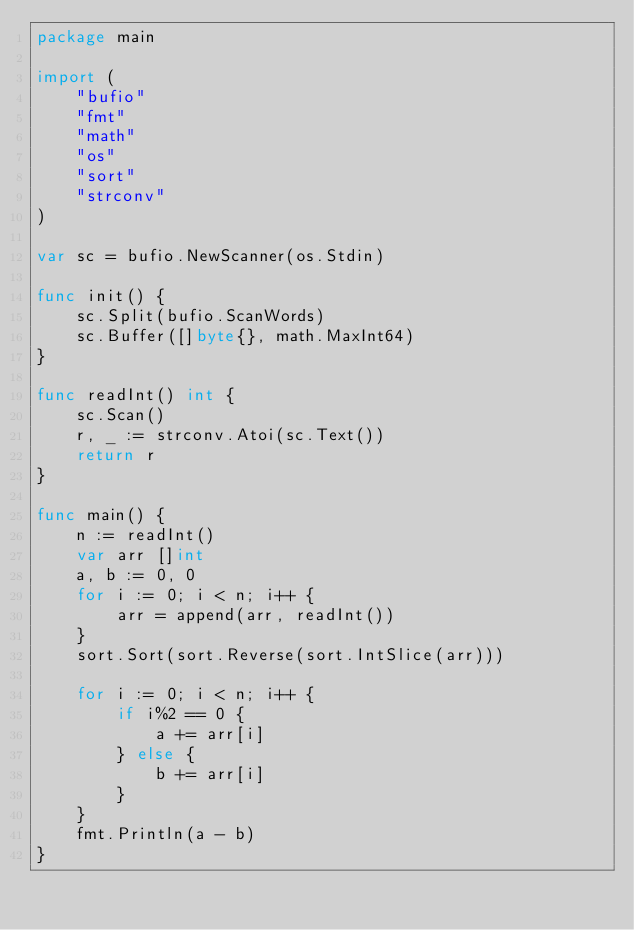Convert code to text. <code><loc_0><loc_0><loc_500><loc_500><_Go_>package main

import (
	"bufio"
	"fmt"
	"math"
	"os"
	"sort"
	"strconv"
)

var sc = bufio.NewScanner(os.Stdin)

func init() {
	sc.Split(bufio.ScanWords)
	sc.Buffer([]byte{}, math.MaxInt64)
}

func readInt() int {
	sc.Scan()
	r, _ := strconv.Atoi(sc.Text())
	return r
}

func main() {
	n := readInt()
	var arr []int
	a, b := 0, 0
	for i := 0; i < n; i++ {
		arr = append(arr, readInt())
	}
	sort.Sort(sort.Reverse(sort.IntSlice(arr)))

	for i := 0; i < n; i++ {
		if i%2 == 0 {
			a += arr[i]
		} else {
			b += arr[i]
		}
	}
	fmt.Println(a - b)
}
</code> 